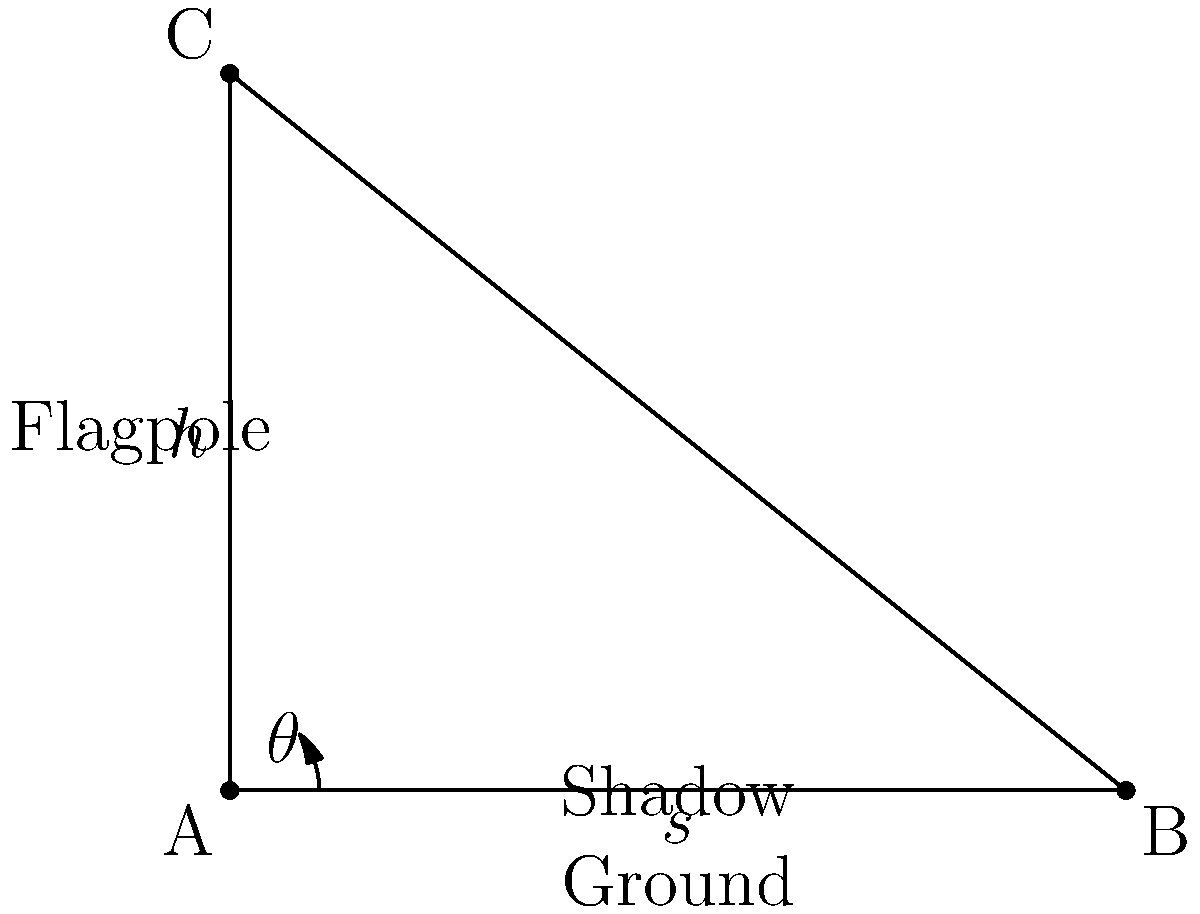In the context of Stephen Carter's novel "New England White," a flagpole stands tall outside the university where the protagonist, Julia Carlyle, works. The flagpole casts a shadow on the ground, creating a right triangle. If the angle of elevation of the sun is $38.7^\circ$ and the height of the flagpole is 20 feet, what is the length of the shadow to the nearest tenth of a foot? Let's approach this step-by-step:

1) We have a right triangle where:
   - The flagpole is the opposite side (let's call its height $h$)
   - The shadow is the adjacent side (let's call its length $s$)
   - The angle of elevation of the sun is $\theta$

2) We know that:
   - $h = 20$ feet
   - $\theta = 38.7^\circ$

3) We need to find $s$. In a right triangle, the tangent of an angle is the ratio of the opposite side to the adjacent side:

   $\tan \theta = \frac{\text{opposite}}{\text{adjacent}} = \frac{h}{s}$

4) We can rearrange this to solve for $s$:

   $s = \frac{h}{\tan \theta}$

5) Now we can plug in our known values:

   $s = \frac{20}{\tan 38.7^\circ}$

6) Using a calculator:

   $s \approx 25.3$ feet

7) Rounding to the nearest tenth:

   $s \approx 25.3$ feet
Answer: 25.3 feet 